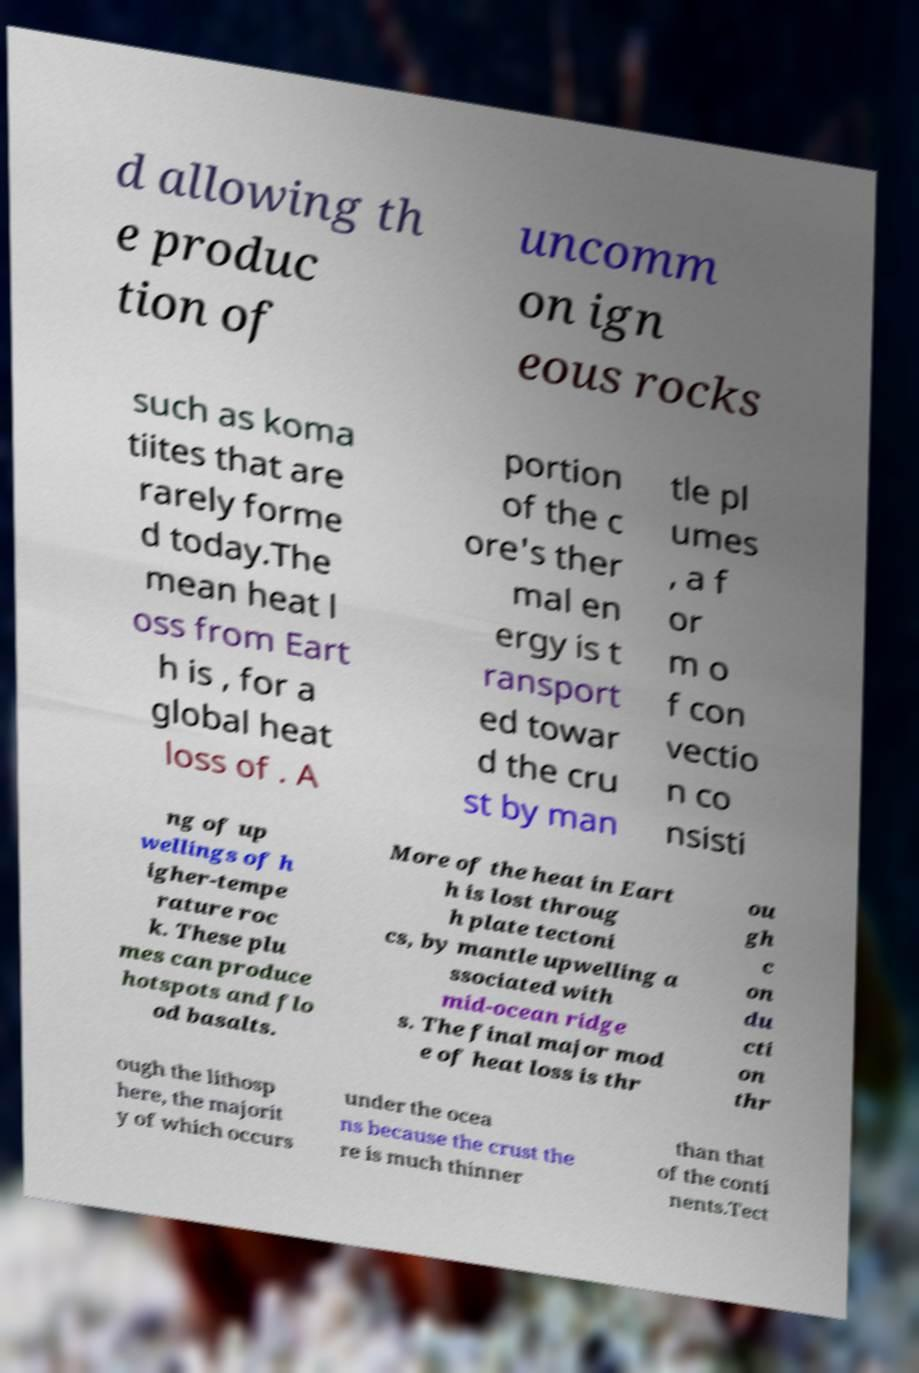Please identify and transcribe the text found in this image. d allowing th e produc tion of uncomm on ign eous rocks such as koma tiites that are rarely forme d today.The mean heat l oss from Eart h is , for a global heat loss of . A portion of the c ore's ther mal en ergy is t ransport ed towar d the cru st by man tle pl umes , a f or m o f con vectio n co nsisti ng of up wellings of h igher-tempe rature roc k. These plu mes can produce hotspots and flo od basalts. More of the heat in Eart h is lost throug h plate tectoni cs, by mantle upwelling a ssociated with mid-ocean ridge s. The final major mod e of heat loss is thr ou gh c on du cti on thr ough the lithosp here, the majorit y of which occurs under the ocea ns because the crust the re is much thinner than that of the conti nents.Tect 